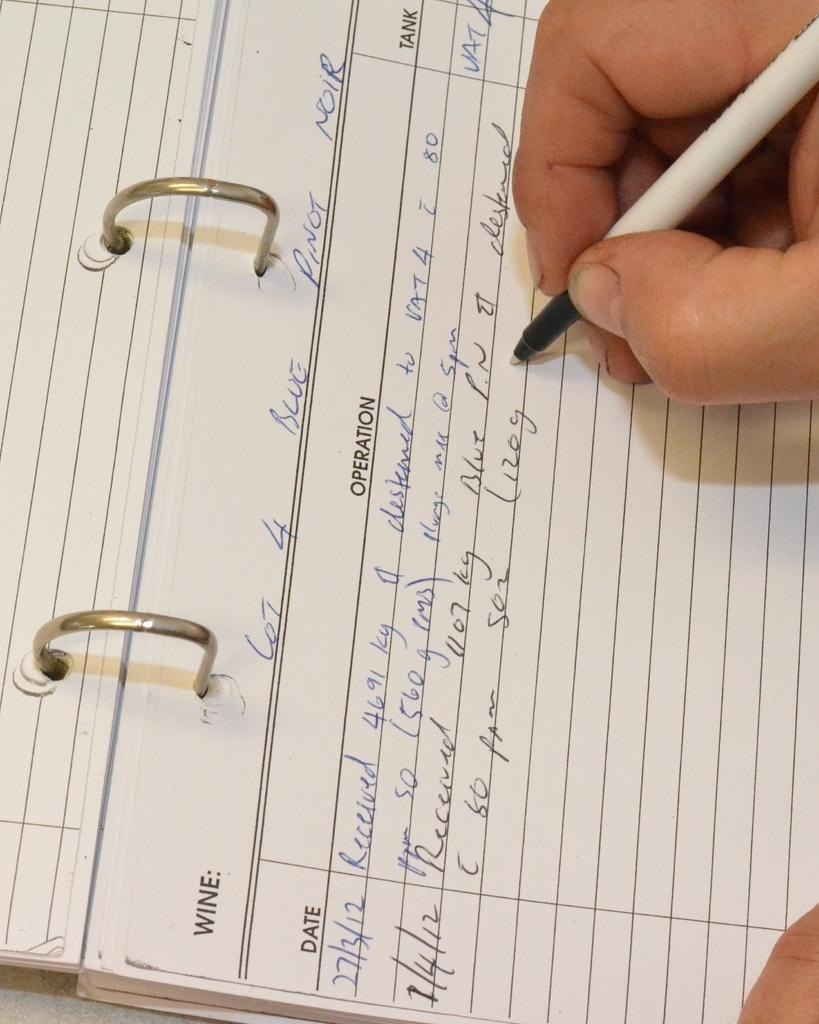What object is present in the image that is commonly used for writing? There is a notepad in the image. What is the person's hand doing in the image? There is a person's hand holding a pen in the image. What type of wire can be seen connecting the notepad to the pen in the image? There is no wire connecting the notepad to the pen in the image. What type of verse is being written by the person holding the pen in the image? There is no verse being written in the image; it only shows a person's hand holding a pen. 